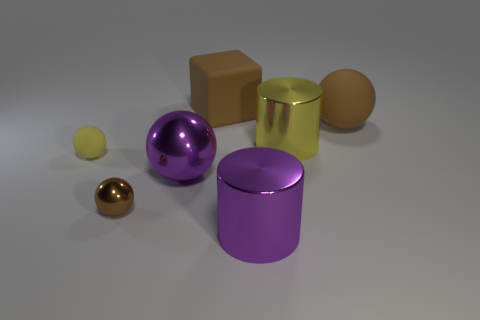Subtract all large brown spheres. How many spheres are left? 3 Add 2 purple metallic things. How many objects exist? 9 Subtract all yellow cubes. How many brown balls are left? 2 Subtract all purple cylinders. How many cylinders are left? 1 Subtract all blocks. How many objects are left? 6 Add 5 large metal spheres. How many large metal spheres are left? 6 Add 3 purple things. How many purple things exist? 5 Subtract 1 yellow cylinders. How many objects are left? 6 Subtract all cyan balls. Subtract all cyan cubes. How many balls are left? 4 Subtract all large purple metallic cylinders. Subtract all big purple metallic spheres. How many objects are left? 5 